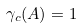<formula> <loc_0><loc_0><loc_500><loc_500>\gamma _ { c } ( A ) = 1</formula> 